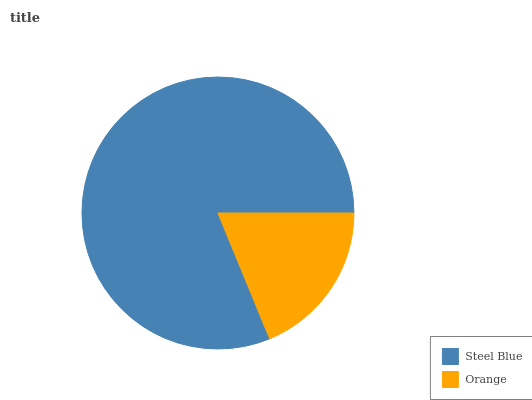Is Orange the minimum?
Answer yes or no. Yes. Is Steel Blue the maximum?
Answer yes or no. Yes. Is Orange the maximum?
Answer yes or no. No. Is Steel Blue greater than Orange?
Answer yes or no. Yes. Is Orange less than Steel Blue?
Answer yes or no. Yes. Is Orange greater than Steel Blue?
Answer yes or no. No. Is Steel Blue less than Orange?
Answer yes or no. No. Is Steel Blue the high median?
Answer yes or no. Yes. Is Orange the low median?
Answer yes or no. Yes. Is Orange the high median?
Answer yes or no. No. Is Steel Blue the low median?
Answer yes or no. No. 